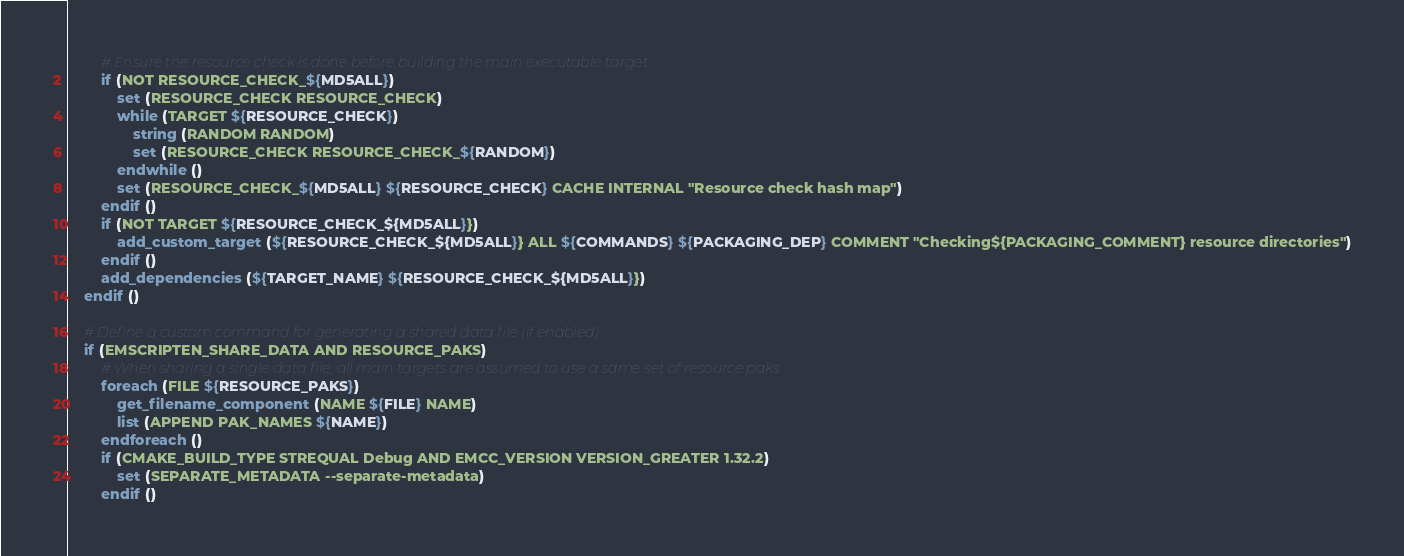Convert code to text. <code><loc_0><loc_0><loc_500><loc_500><_CMake_>        # Ensure the resource check is done before building the main executable target
        if (NOT RESOURCE_CHECK_${MD5ALL})
            set (RESOURCE_CHECK RESOURCE_CHECK)
            while (TARGET ${RESOURCE_CHECK})
                string (RANDOM RANDOM)
                set (RESOURCE_CHECK RESOURCE_CHECK_${RANDOM})
            endwhile ()
            set (RESOURCE_CHECK_${MD5ALL} ${RESOURCE_CHECK} CACHE INTERNAL "Resource check hash map")
        endif ()
        if (NOT TARGET ${RESOURCE_CHECK_${MD5ALL}})
            add_custom_target (${RESOURCE_CHECK_${MD5ALL}} ALL ${COMMANDS} ${PACKAGING_DEP} COMMENT "Checking${PACKAGING_COMMENT} resource directories")
        endif ()
        add_dependencies (${TARGET_NAME} ${RESOURCE_CHECK_${MD5ALL}})
    endif ()

    # Define a custom command for generating a shared data file (if enabled)
    if (EMSCRIPTEN_SHARE_DATA AND RESOURCE_PAKS)
        # When sharing a single data file, all main targets are assumed to use a same set of resource paks
        foreach (FILE ${RESOURCE_PAKS})
            get_filename_component (NAME ${FILE} NAME)
            list (APPEND PAK_NAMES ${NAME})
        endforeach ()
        if (CMAKE_BUILD_TYPE STREQUAL Debug AND EMCC_VERSION VERSION_GREATER 1.32.2)
            set (SEPARATE_METADATA --separate-metadata)
        endif ()</code> 